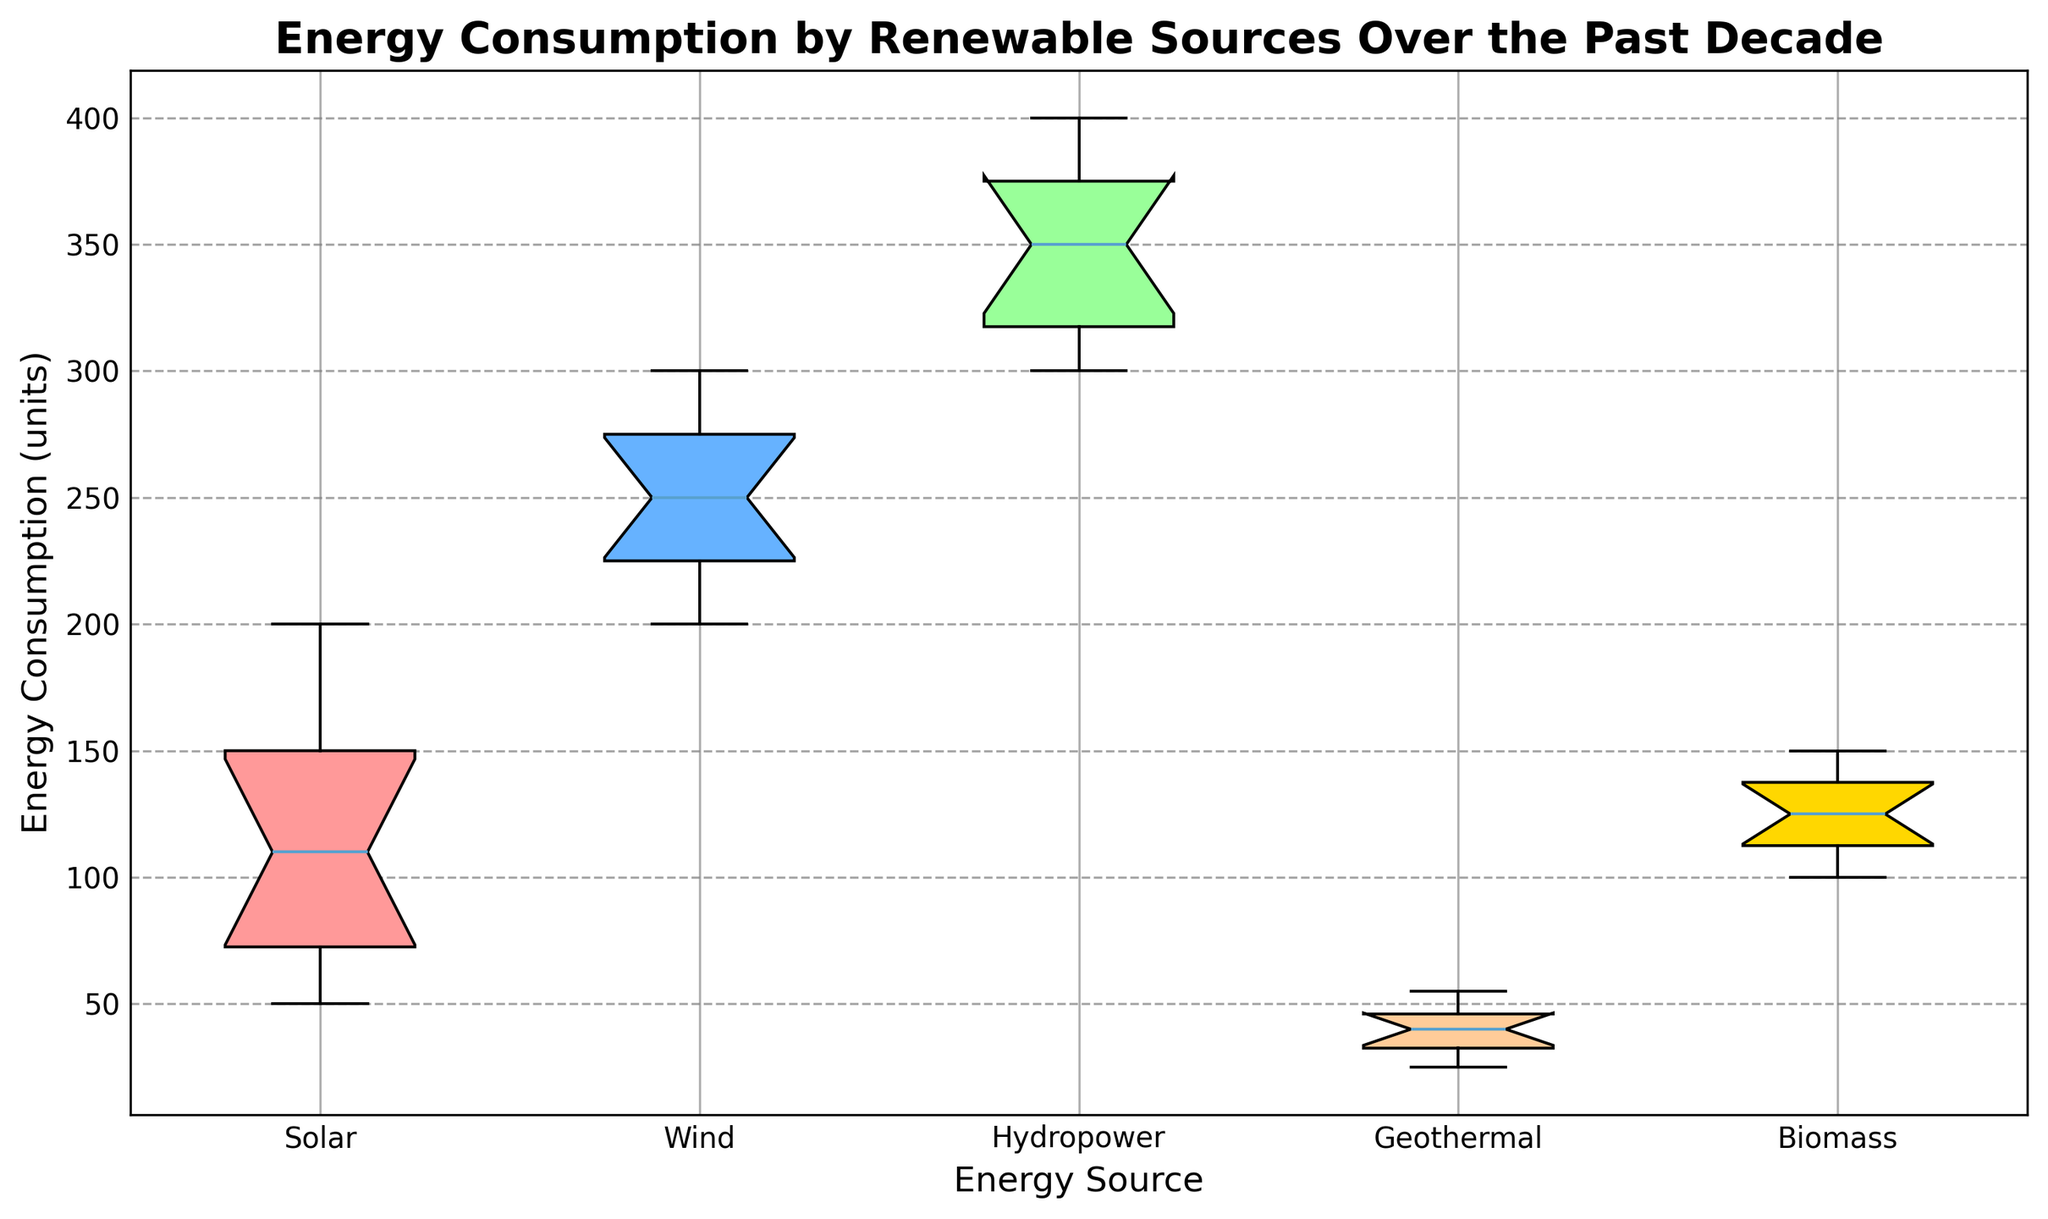What is the median energy consumption for Solar energy over the past decade? To find the median energy consumption for Solar energy, look at the box plot for Solar. The median value is indicated by the line inside the box.
Answer: 110 Which energy source has the widest range of energy consumption values in the box plot? The range is determined by the length of the whiskers from the minimum to the maximum values. By inspecting the box plot, Hydropower has the widest range between its minimum and maximum values.
Answer: Hydropower Among Solar and Wind energy, which one shows a higher interquartile range (IQR)? The IQR is the height of the box, which shows the range between the 25th percentile (Q1) and the 75th percentile (Q3). By comparing the boxes between Solar and Wind, Solar has a higher IQR.
Answer: Solar Comparing the median values of Biomass and Geothermal energy sources, which one is higher? To compare medians, examine the line inside the boxes for Biomass and Geothermal. Biomass has a higher median value than Geothermal.
Answer: Biomass What is the approximate difference between the maximum energy consumption of Wind and Solar energy? Look at the top whisker for both Wind and Solar to find the maximum values. Wind has a maximum value around 300 and Solar has around 200. The difference is 300 - 200 = 100.
Answer: 100 Which energy source appears to be the most consistent in its energy consumption over the past decade? Consistency can be identified by a smaller range and tighter IQR. By inspecting the box plots, Wind shows a narrower range and smaller IQR compared to other sources.
Answer: Wind How does the median energy consumption for Hydropower compare to the upper quartile (75th percentile) of Solar energy? Examine the line inside the Hydropower box for the median and the top line of the Solar box for the 75th percentile (Q3). Hydropower's median is higher than Solar's upper quartile.
Answer: Hydropower's median is higher What color box represents Geothermal energy, and where is it positioned on the x-axis? Geothermal energy is represented with a lighter yellowish color box and is positioned fourth from the left on the x-axis.
Answer: Yellowish, fourth Considering the lowest quartile (25th percentile) of Biomass and Geothermal, which is higher? The 25th percentile is indicated by the bottom line of the box. By comparing Biomass and Geothermal, Biomass has a higher 25th percentile.
Answer: Biomass Summing up the median values of Solar and Biomass, what is the result? The median values for Solar and Biomass are 110 and 125 respectively. Summing these values results in 110 + 125 = 235
Answer: 235 